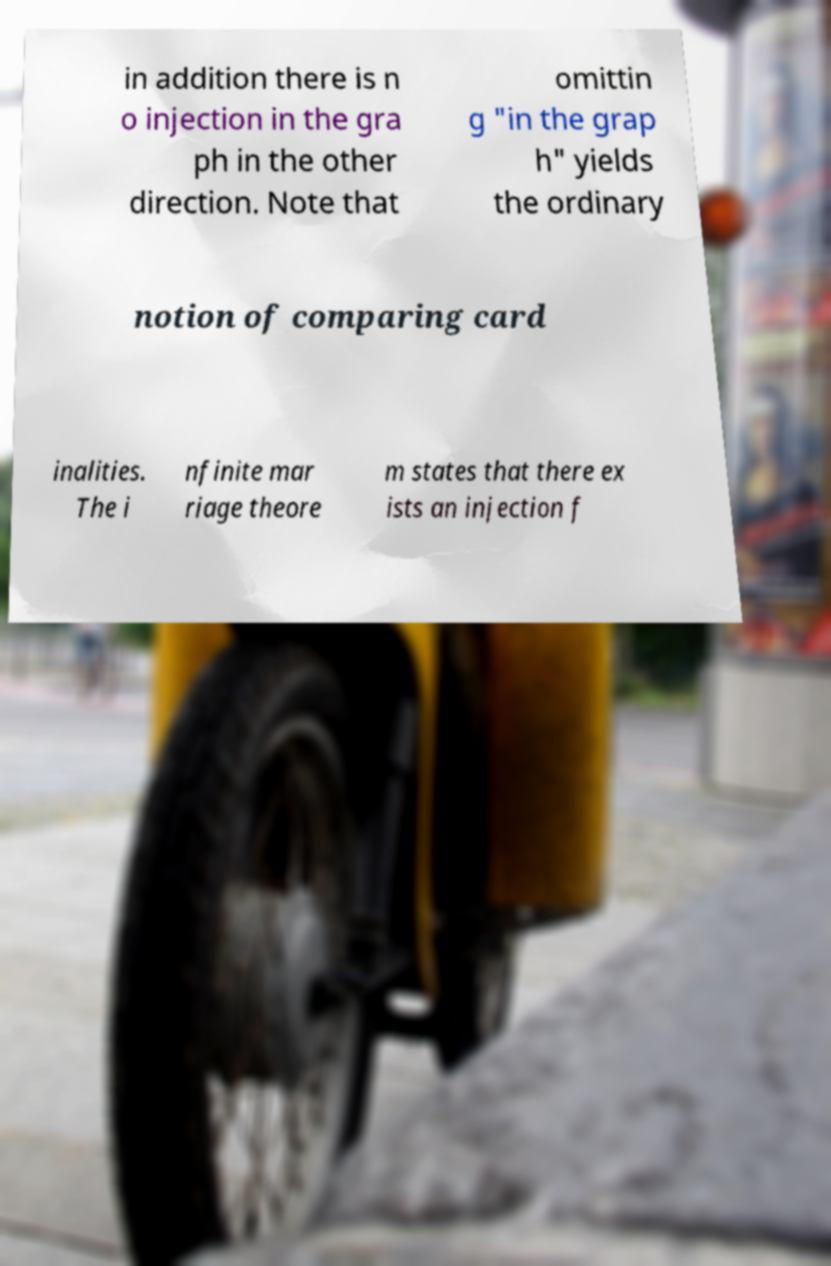Could you extract and type out the text from this image? in addition there is n o injection in the gra ph in the other direction. Note that omittin g "in the grap h" yields the ordinary notion of comparing card inalities. The i nfinite mar riage theore m states that there ex ists an injection f 